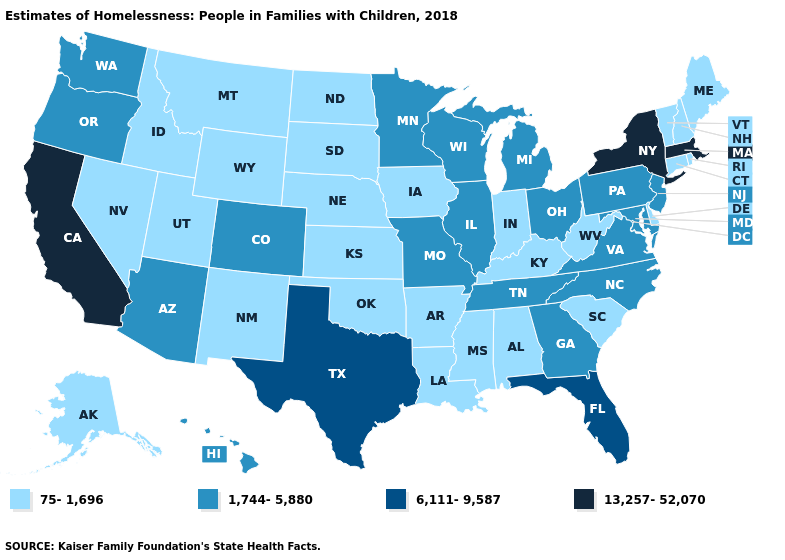Which states have the lowest value in the USA?
Quick response, please. Alabama, Alaska, Arkansas, Connecticut, Delaware, Idaho, Indiana, Iowa, Kansas, Kentucky, Louisiana, Maine, Mississippi, Montana, Nebraska, Nevada, New Hampshire, New Mexico, North Dakota, Oklahoma, Rhode Island, South Carolina, South Dakota, Utah, Vermont, West Virginia, Wyoming. Name the states that have a value in the range 13,257-52,070?
Keep it brief. California, Massachusetts, New York. Among the states that border Nebraska , which have the lowest value?
Give a very brief answer. Iowa, Kansas, South Dakota, Wyoming. Does the first symbol in the legend represent the smallest category?
Answer briefly. Yes. What is the highest value in states that border North Carolina?
Concise answer only. 1,744-5,880. What is the value of Oklahoma?
Give a very brief answer. 75-1,696. Does North Dakota have the lowest value in the USA?
Keep it brief. Yes. What is the value of Alabama?
Concise answer only. 75-1,696. Does Nevada have a higher value than Iowa?
Short answer required. No. Among the states that border North Carolina , does South Carolina have the highest value?
Answer briefly. No. What is the value of Kentucky?
Give a very brief answer. 75-1,696. What is the highest value in the USA?
Answer briefly. 13,257-52,070. Does Massachusetts have the highest value in the Northeast?
Concise answer only. Yes. Which states have the lowest value in the South?
Write a very short answer. Alabama, Arkansas, Delaware, Kentucky, Louisiana, Mississippi, Oklahoma, South Carolina, West Virginia. What is the highest value in the West ?
Short answer required. 13,257-52,070. 